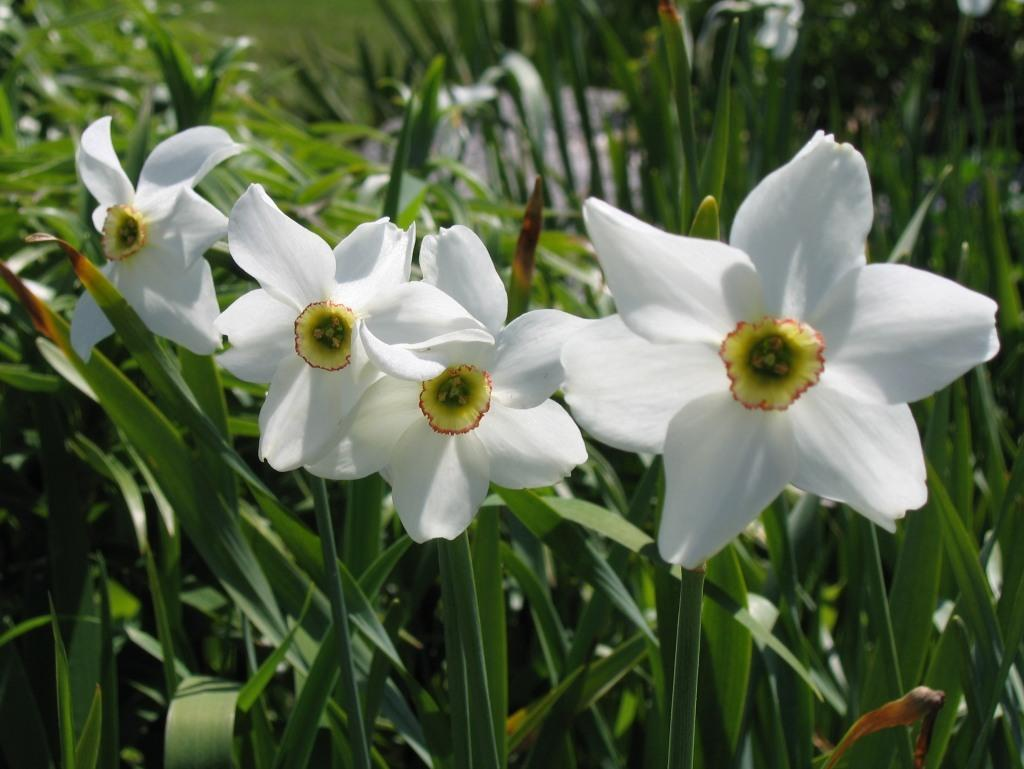What type of living organisms can be seen in the image? Plants can be seen in the image. What specific feature of the plants is visible in the image? The plants have flowers. What colors are the flowers in the image? The flowers are white and yellow in color. Can you hear the hen cry in the image? There is no hen or any sound mentioned in the image, so it is not possible to hear a hen cry. 